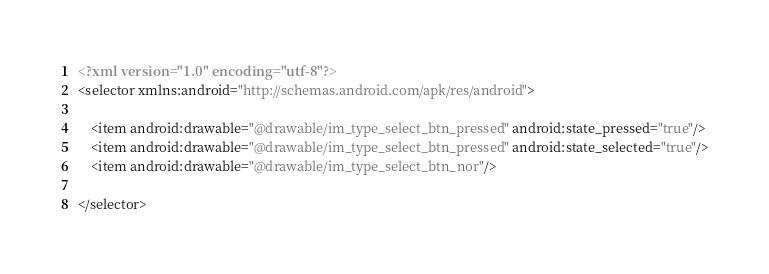Convert code to text. <code><loc_0><loc_0><loc_500><loc_500><_XML_><?xml version="1.0" encoding="utf-8"?>
<selector xmlns:android="http://schemas.android.com/apk/res/android">

    <item android:drawable="@drawable/im_type_select_btn_pressed" android:state_pressed="true"/>
    <item android:drawable="@drawable/im_type_select_btn_pressed" android:state_selected="true"/>
    <item android:drawable="@drawable/im_type_select_btn_nor"/>

</selector></code> 